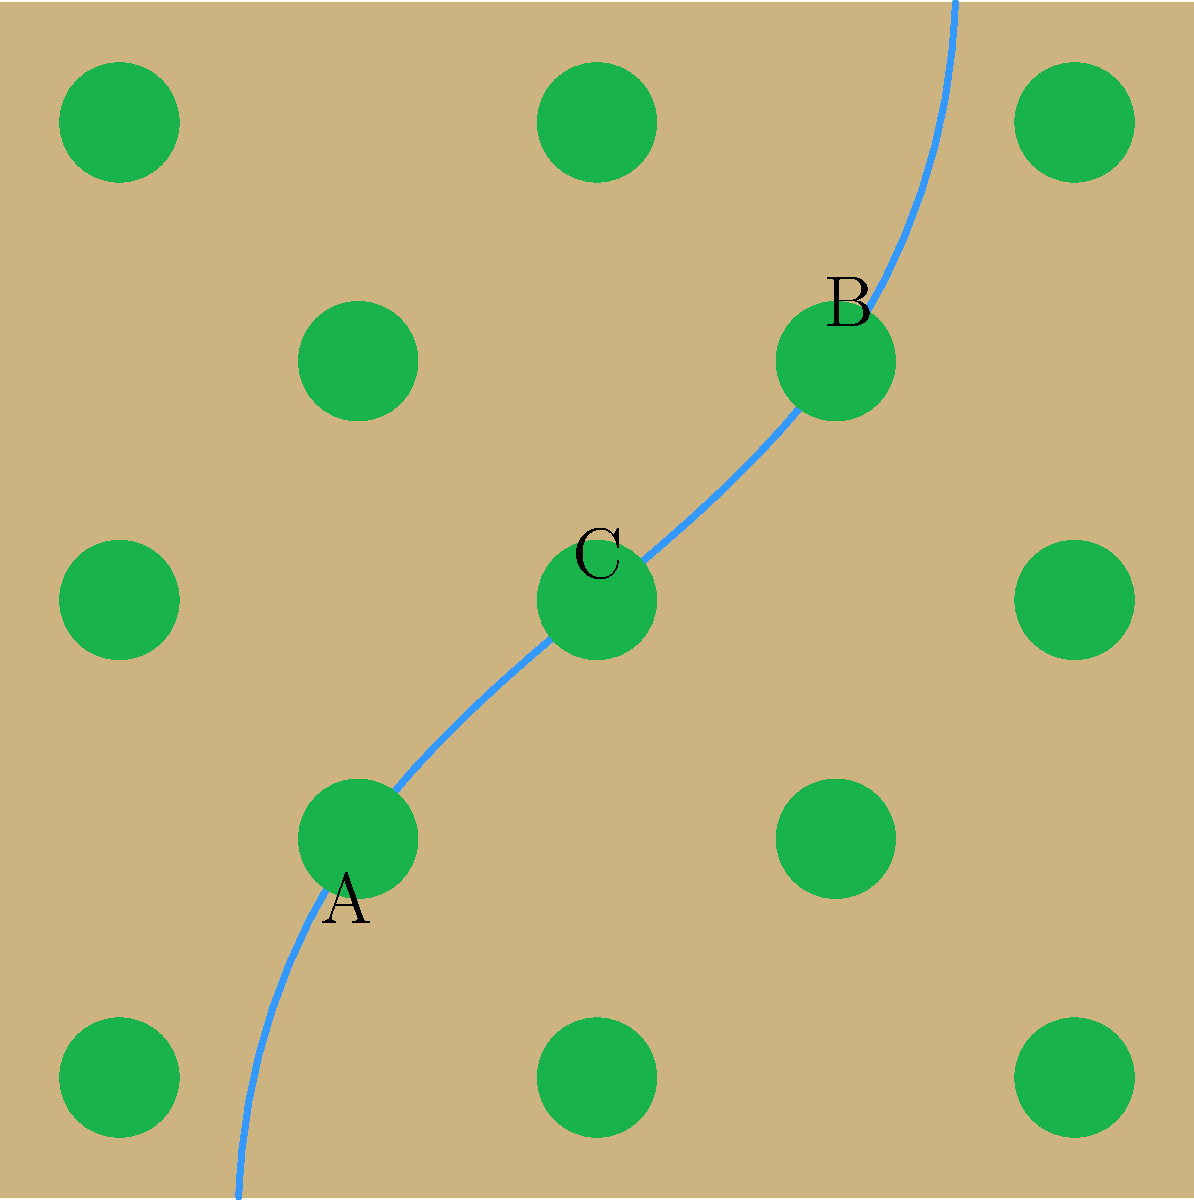Based on the satellite imagery provided, which area is most likely to contain a significant underground water source? To identify potential underground water sources from satellite imagery, we need to consider several factors:

1. Surface water features: Rivers and streams often indicate the presence of groundwater. In the image, we see a blue line representing a river running from the bottom left to the top right.

2. Vegetation patterns: Areas with denser vegetation (represented by green circles) may indicate higher water availability.

3. Topography: Although not explicitly shown, we can infer that the river likely flows through a valley or lower elevation area.

4. Convergence points: Areas where multiple factors coincide are more likely to have significant groundwater resources.

Analyzing the three labeled points:

A: Located near the start of the river, but with less vegetation.
B: Located near the end of the river, with some vegetation nearby.
C: Located at the center of the image, where the river bends and vegetation is densest.

Point C is the most promising location for underground water because:
1. It's at a bend in the river, where water is more likely to accumulate.
2. It has the densest vegetation cover, suggesting consistent water availability.
3. It's centrally located, potentially at a topographic low point where groundwater might converge.

The combination of these factors makes Point C the most likely location for a significant underground water source.
Answer: C 